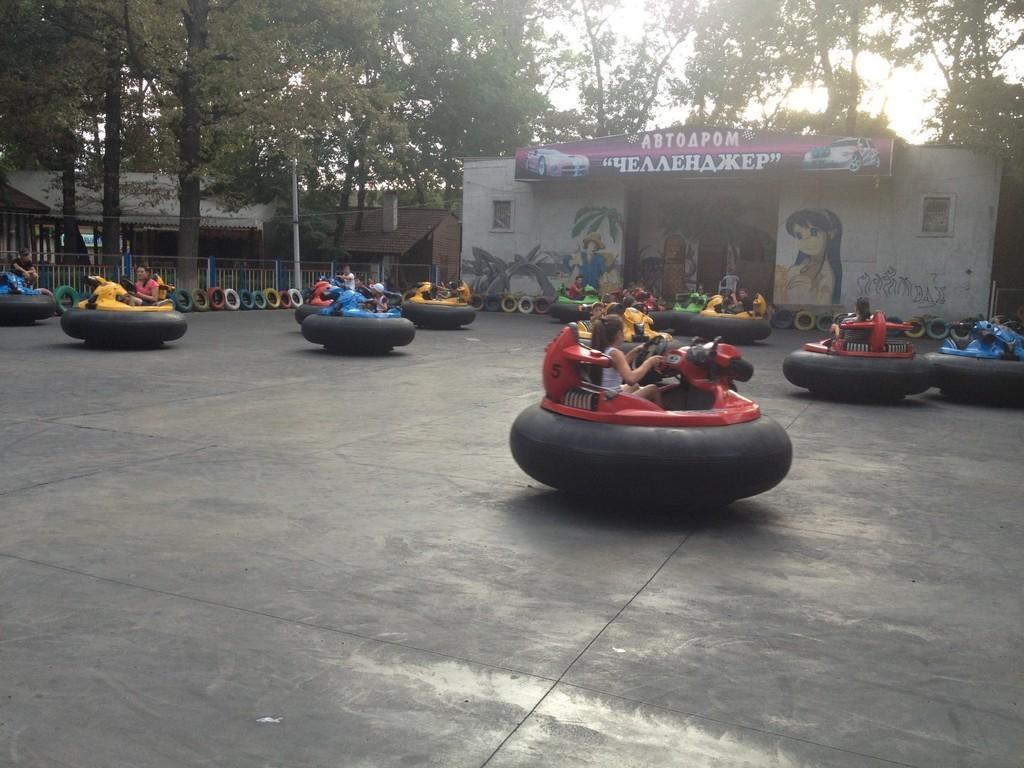Can you describe this image briefly? In this picture I can see there are few people riding the cars and there are few tires arranged in a circle and there is a building in the backdrop with a name plate. There are few trees and the sky is clear and sunny. 